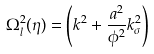Convert formula to latex. <formula><loc_0><loc_0><loc_500><loc_500>\Omega _ { l } ^ { 2 } ( \eta ) = \left ( { k } ^ { 2 } + \frac { a ^ { 2 } } { \phi ^ { 2 } } k _ { \sigma } ^ { 2 } \right )</formula> 